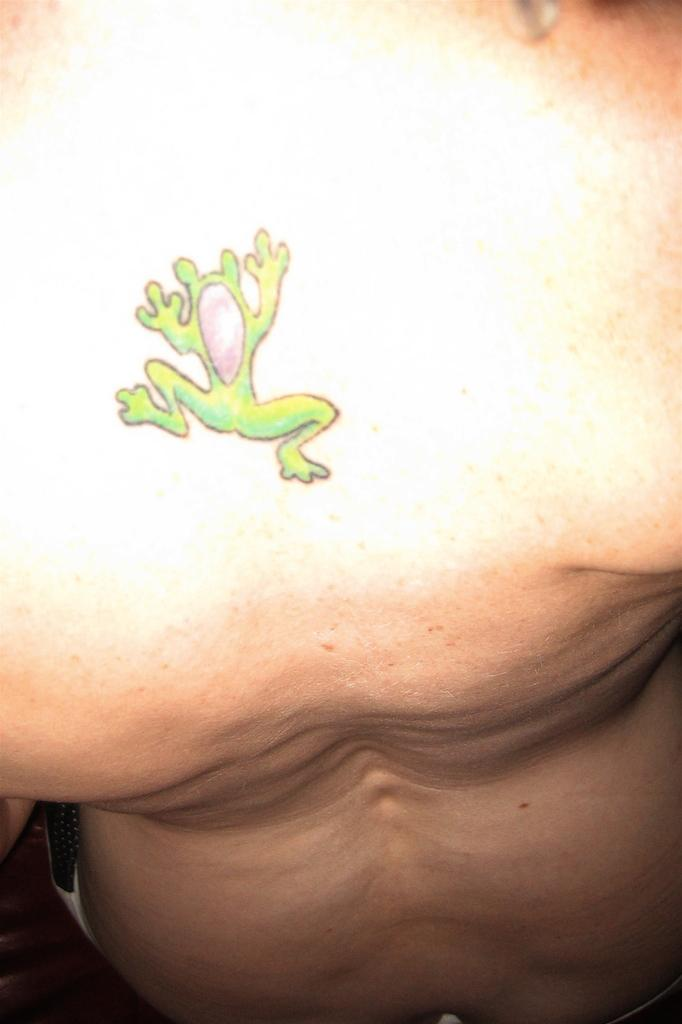What is the main subject of the image? The main subject of the image is a human body. Are there any distinguishing features on the human body? Yes, there is a tattoo on the human body. What type of goldfish can be seen swimming near the tattoo in the image? There are no goldfish present in the image; it features a human body with a tattoo. What type of cast is visible on the human body in the image? There is no cast visible on the human body in the image; it only features a tattoo. 